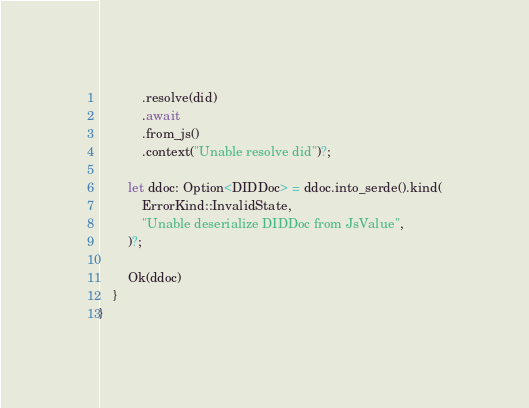Convert code to text. <code><loc_0><loc_0><loc_500><loc_500><_Rust_>            .resolve(did)
            .await
            .from_js()
            .context("Unable resolve did")?;

        let ddoc: Option<DIDDoc> = ddoc.into_serde().kind(
            ErrorKind::InvalidState,
            "Unable deserialize DIDDoc from JsValue",
        )?;

        Ok(ddoc)
    }
}
</code> 